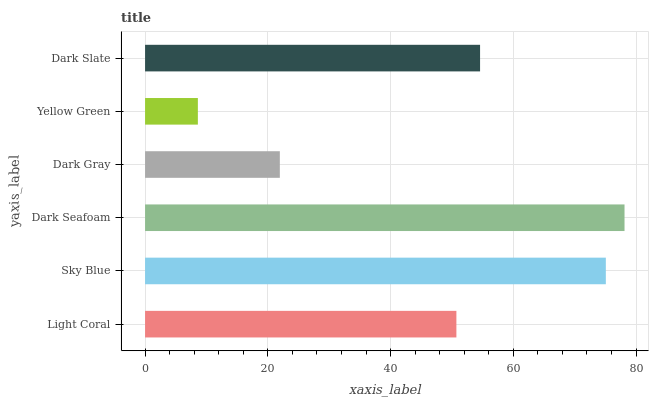Is Yellow Green the minimum?
Answer yes or no. Yes. Is Dark Seafoam the maximum?
Answer yes or no. Yes. Is Sky Blue the minimum?
Answer yes or no. No. Is Sky Blue the maximum?
Answer yes or no. No. Is Sky Blue greater than Light Coral?
Answer yes or no. Yes. Is Light Coral less than Sky Blue?
Answer yes or no. Yes. Is Light Coral greater than Sky Blue?
Answer yes or no. No. Is Sky Blue less than Light Coral?
Answer yes or no. No. Is Dark Slate the high median?
Answer yes or no. Yes. Is Light Coral the low median?
Answer yes or no. Yes. Is Dark Seafoam the high median?
Answer yes or no. No. Is Dark Seafoam the low median?
Answer yes or no. No. 